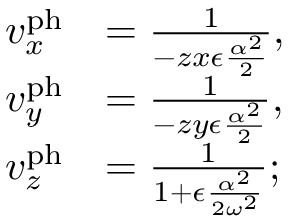<formula> <loc_0><loc_0><loc_500><loc_500>\begin{array} { r l } { v _ { x } ^ { p h } } & { = \frac { 1 } { - z x \epsilon \frac { \alpha ^ { 2 } } { 2 } } , } \\ { v _ { y } ^ { p h } } & { = \frac { 1 } { - z y \epsilon \frac { \alpha ^ { 2 } } { 2 } } , } \\ { v _ { z } ^ { p h } } & { = \frac { 1 } { 1 + \epsilon \frac { \alpha ^ { 2 } } { 2 \omega ^ { 2 } } } ; } \end{array}</formula> 